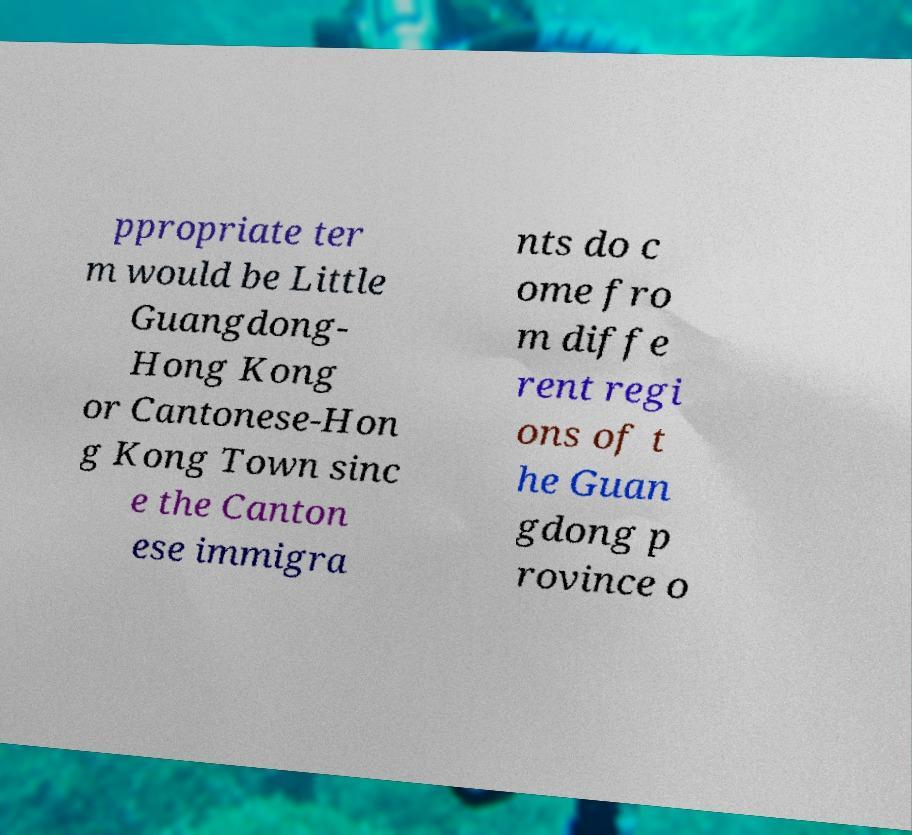Please identify and transcribe the text found in this image. ppropriate ter m would be Little Guangdong- Hong Kong or Cantonese-Hon g Kong Town sinc e the Canton ese immigra nts do c ome fro m diffe rent regi ons of t he Guan gdong p rovince o 